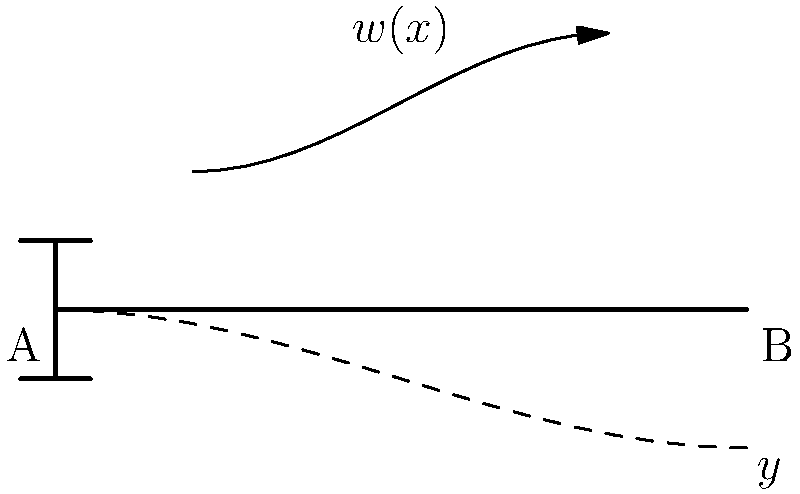A cantilever beam AB of length L is subjected to a non-uniform distributed load $w(x) = w_0(1 - \frac{x}{L})$, where $w_0$ is the maximum load intensity at the fixed end. If the beam has a constant flexural rigidity EI, determine the expression for the maximum deflection at the free end B. To solve this problem, we'll follow these steps:

1) The governing differential equation for beam deflection is:

   $$\frac{d^4y}{dx^4} = \frac{w(x)}{EI}$$

2) Substitute the given load distribution:

   $$\frac{d^4y}{dx^4} = \frac{w_0}{EI}(1 - \frac{x}{L})$$

3) Integrate four times to get the deflection equation:

   $$\frac{d^3y}{dx^3} = \frac{w_0}{EI}(x - \frac{x^2}{2L}) + C_1$$
   
   $$\frac{d^2y}{dx^2} = \frac{w_0}{EI}(\frac{x^2}{2} - \frac{x^3}{6L}) + C_1x + C_2$$
   
   $$\frac{dy}{dx} = \frac{w_0}{EI}(\frac{x^3}{6} - \frac{x^4}{24L}) + \frac{C_1x^2}{2} + C_2x + C_3$$
   
   $$y = \frac{w_0}{EI}(\frac{x^4}{24} - \frac{x^5}{120L}) + \frac{C_1x^3}{6} + \frac{C_2x^2}{2} + C_3x + C_4$$

4) Apply boundary conditions:
   At x = 0 (fixed end): y = 0, dy/dx = 0
   At x = L (free end): d^2y/dx^2 = 0, d^3y/dx^3 = 0

5) Solve for constants C1, C2, C3, and C4

6) Substitute x = L in the final equation to get the maximum deflection:

   $$y_{max} = \frac{w_0L^4}{120EI}$$
Answer: $\frac{w_0L^4}{120EI}$ 